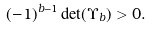<formula> <loc_0><loc_0><loc_500><loc_500>( - 1 ) ^ { b - 1 } \det ( \Upsilon _ { b } ) > 0 .</formula> 